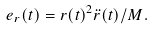<formula> <loc_0><loc_0><loc_500><loc_500>e _ { r } ( t ) = r ( t ) ^ { 2 } \ddot { r } ( t ) / M .</formula> 